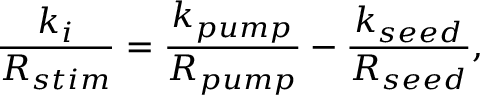<formula> <loc_0><loc_0><loc_500><loc_500>\frac { k _ { i } } { R _ { s t i m } } = \frac { k _ { p u m p } } { R _ { p u m p } } - \frac { k _ { s e e d } } { R _ { s e e d } } ,</formula> 